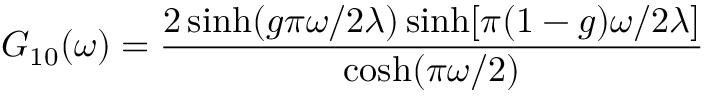<formula> <loc_0><loc_0><loc_500><loc_500>G _ { 1 0 } ( \omega ) = \frac { 2 \sinh ( g \pi \omega / 2 \lambda ) \sinh [ \pi ( 1 - g ) \omega / 2 \lambda ] } { \cosh ( \pi \omega / 2 ) }</formula> 